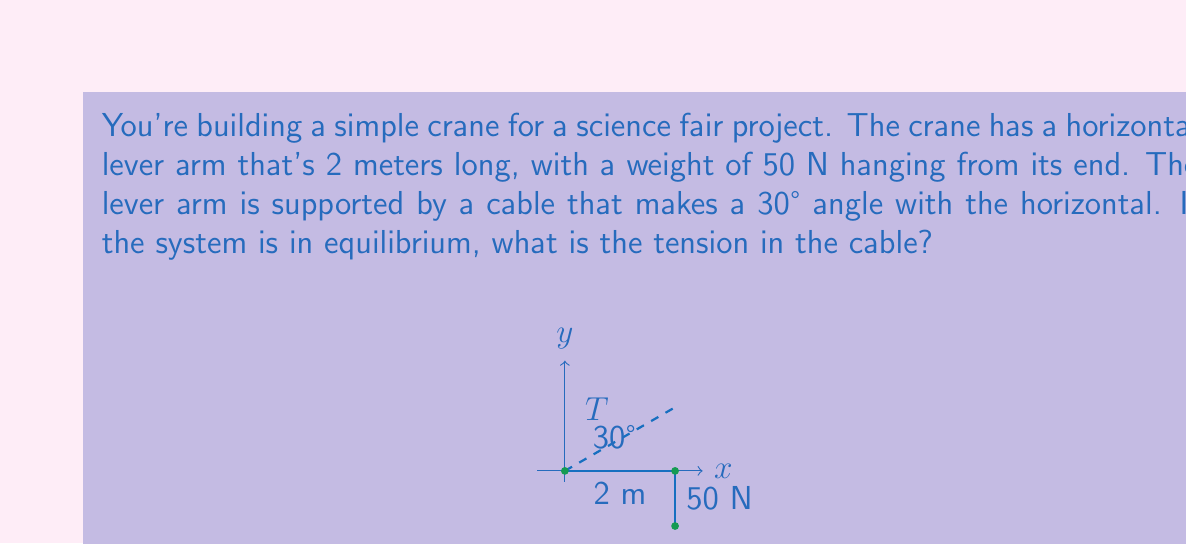Give your solution to this math problem. Let's approach this step-by-step:

1) First, we need to understand the forces acting on the lever arm:
   - The weight (50 N) acting downward at the end of the arm
   - The tension (T) in the cable
   - The reaction force at the pivot point (which we don't need to calculate)

2) For equilibrium, the sum of moments about the pivot point must be zero. We'll use this to find the tension.

3) The moment caused by the weight:
   $M_{weight} = 50 \text{ N} \times 2 \text{ m} = 100 \text{ N⋅m}$

4) The moment caused by the tension:
   - The lever arm for the tension is the perpendicular distance from the pivot to the line of action of the tension force.
   - This distance is $2 \text{ m} \times \sin(30°)$

5) Setting up the equation for equilibrium of moments:
   $T \times (2 \text{ m} \times \sin(30°)) = 100 \text{ N⋅m}$

6) Solving for T:
   $$T = \frac{100 \text{ N⋅m}}{2 \text{ m} \times \sin(30°)}$$

7) Calculate:
   $$T = \frac{100}{2 \times 0.5} = 100 \text{ N}$$

Therefore, the tension in the cable is 100 N.
Answer: 100 N 